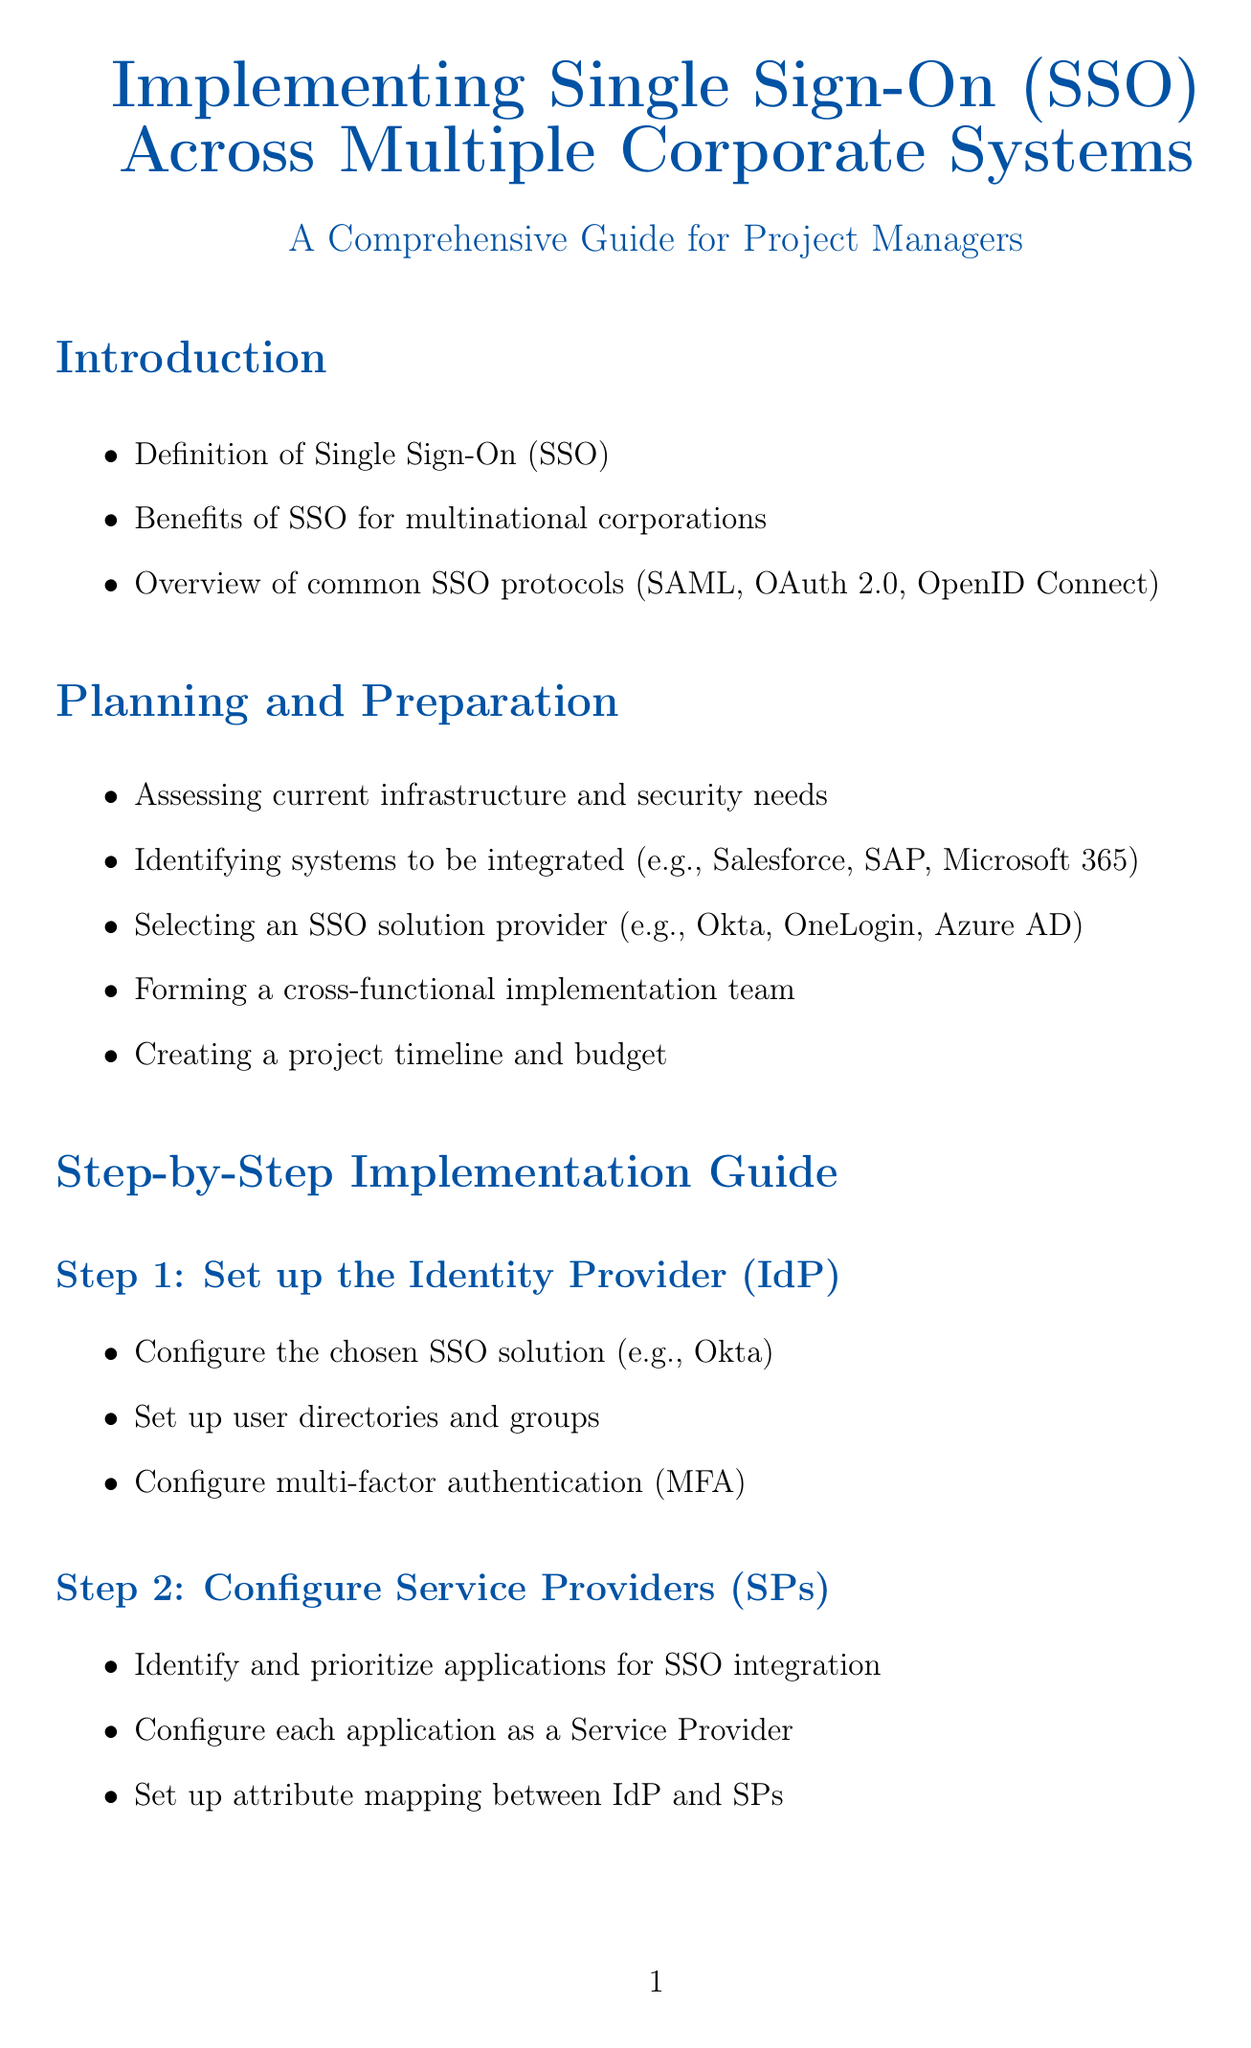What are the common SSO protocols? The common SSO protocols mentioned in the document are SAML, OAuth 2.0, and OpenID Connect.
Answer: SAML, OAuth 2.0, OpenID Connect What is the first step in the implementation guide? The first step in the implementation guide is to set up the Identity Provider (IdP).
Answer: Set up the Identity Provider (IdP) Which security practice is recommended for all users? The document recommends implementing multi-factor authentication (MFA) for all users.
Answer: Multi-factor authentication (MFA) What challenge is associated with legacy system integration? The challenge associated with legacy system integration is identified as using federation proxies or custom connectors for non-standard applications.
Answer: Use federation proxies or custom connectors What is the purpose of establishing trust relationships? Establishing trust relationships involves exchanging metadata between IdP and SPs and configuring secure communication.
Answer: Secure communication How many steps are there in the step-by-step implementation guide? The step-by-step implementation guide includes six steps.
Answer: Six steps What does SSO stand for? SSO stands for Single Sign-On.
Answer: Single Sign-On What is a recommended solution for mobile app integration? The recommended solution for mobile app integration is to implement mobile SSO using OAuth 2.0 and OpenID Connect.
Answer: Mobile SSO using OAuth 2.0 and OpenID Connect 